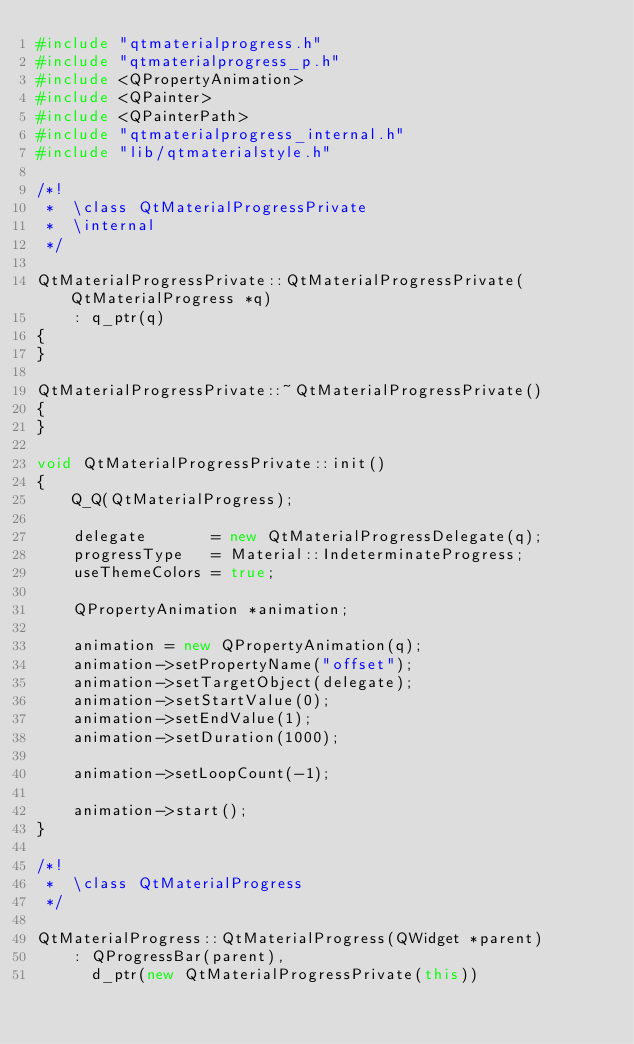<code> <loc_0><loc_0><loc_500><loc_500><_C++_>#include "qtmaterialprogress.h"
#include "qtmaterialprogress_p.h"
#include <QPropertyAnimation>
#include <QPainter>
#include <QPainterPath>
#include "qtmaterialprogress_internal.h"
#include "lib/qtmaterialstyle.h"

/*!
 *  \class QtMaterialProgressPrivate
 *  \internal
 */

QtMaterialProgressPrivate::QtMaterialProgressPrivate(QtMaterialProgress *q)
    : q_ptr(q)
{
}

QtMaterialProgressPrivate::~QtMaterialProgressPrivate()
{
}

void QtMaterialProgressPrivate::init()
{
    Q_Q(QtMaterialProgress);

    delegate       = new QtMaterialProgressDelegate(q);
    progressType   = Material::IndeterminateProgress;
    useThemeColors = true;

    QPropertyAnimation *animation;

    animation = new QPropertyAnimation(q);
    animation->setPropertyName("offset");
    animation->setTargetObject(delegate);
    animation->setStartValue(0);
    animation->setEndValue(1);
    animation->setDuration(1000);

    animation->setLoopCount(-1);

    animation->start();
}

/*!
 *  \class QtMaterialProgress
 */

QtMaterialProgress::QtMaterialProgress(QWidget *parent)
    : QProgressBar(parent),
      d_ptr(new QtMaterialProgressPrivate(this))</code> 